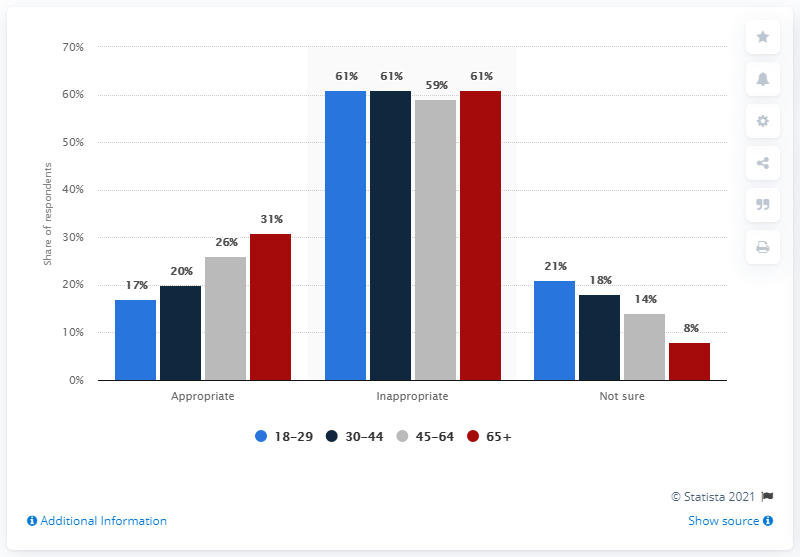Mention a couple of crucial points in this snapshot. The average of the red bars is 33.33... The most opinion among the age group of 65 and above is more than the least opinion. The age group 65 and above have a total of 53 opinions. 